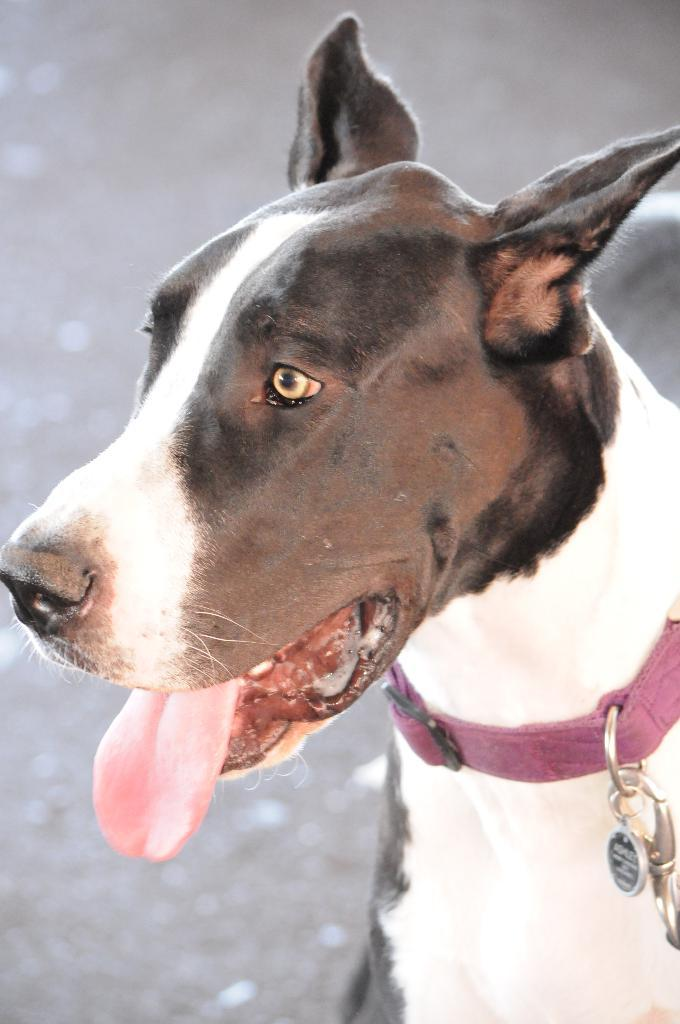What is the main subject in the foreground of the picture? There is a dog in the foreground of the picture. Where is the goldfish swimming in the picture? There is no goldfish present in the picture; the main subject is a dog. 